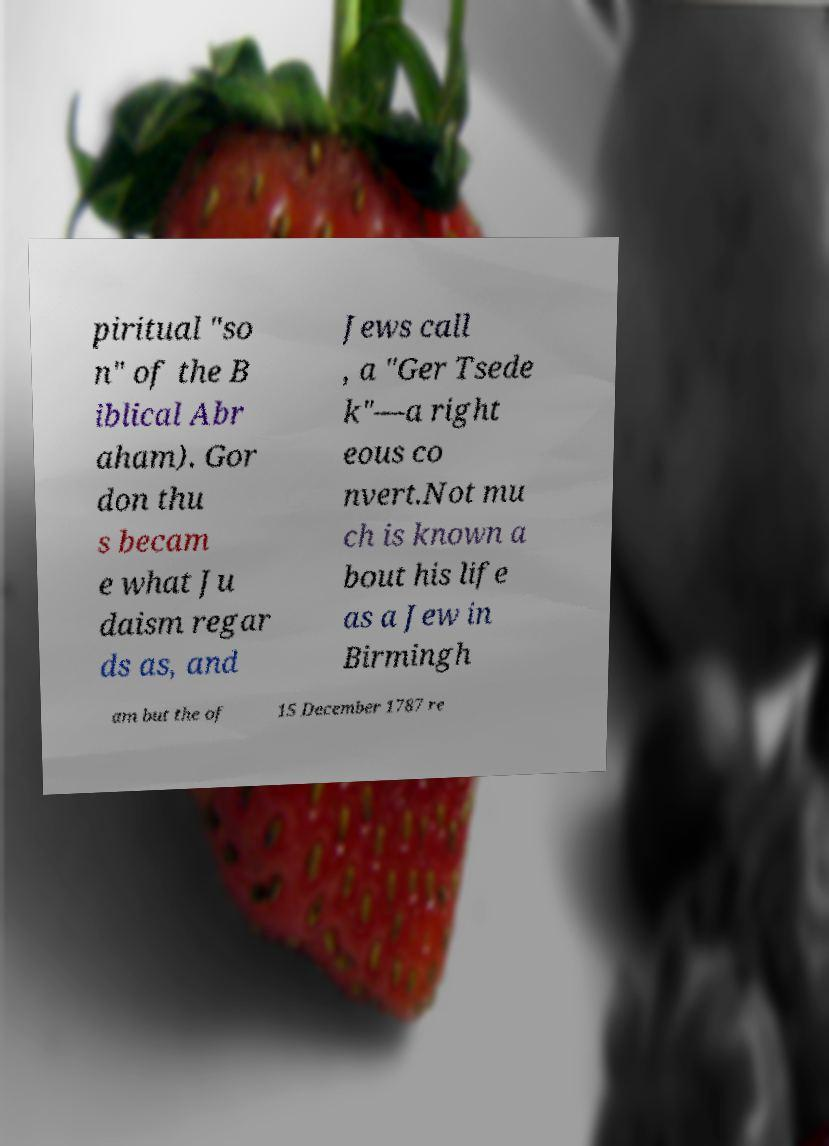I need the written content from this picture converted into text. Can you do that? piritual "so n" of the B iblical Abr aham). Gor don thu s becam e what Ju daism regar ds as, and Jews call , a "Ger Tsede k"—a right eous co nvert.Not mu ch is known a bout his life as a Jew in Birmingh am but the of 15 December 1787 re 